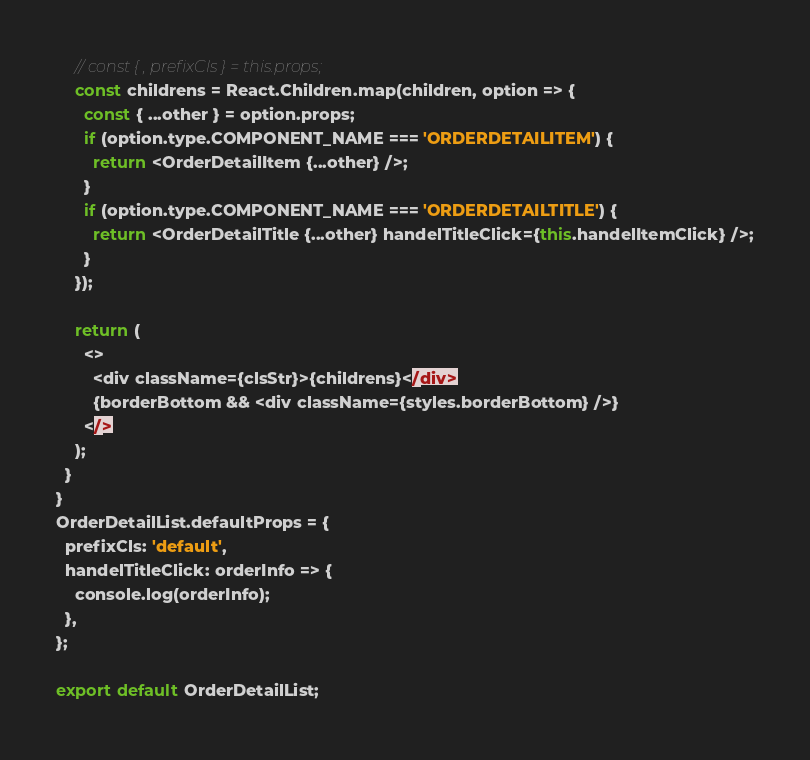<code> <loc_0><loc_0><loc_500><loc_500><_JavaScript_>    // const { , prefixCls } = this.props;
    const childrens = React.Children.map(children, option => {
      const { ...other } = option.props;
      if (option.type.COMPONENT_NAME === 'ORDERDETAILITEM') {
        return <OrderDetailItem {...other} />;
      }
      if (option.type.COMPONENT_NAME === 'ORDERDETAILTITLE') {
        return <OrderDetailTitle {...other} handelTitleClick={this.handelItemClick} />;
      }
    });

    return (
      <>
        <div className={clsStr}>{childrens}</div>
        {borderBottom && <div className={styles.borderBottom} />}
      </>
    );
  }
}
OrderDetailList.defaultProps = {
  prefixCls: 'default',
  handelTitleClick: orderInfo => {
    console.log(orderInfo);
  },
};

export default OrderDetailList;
</code> 